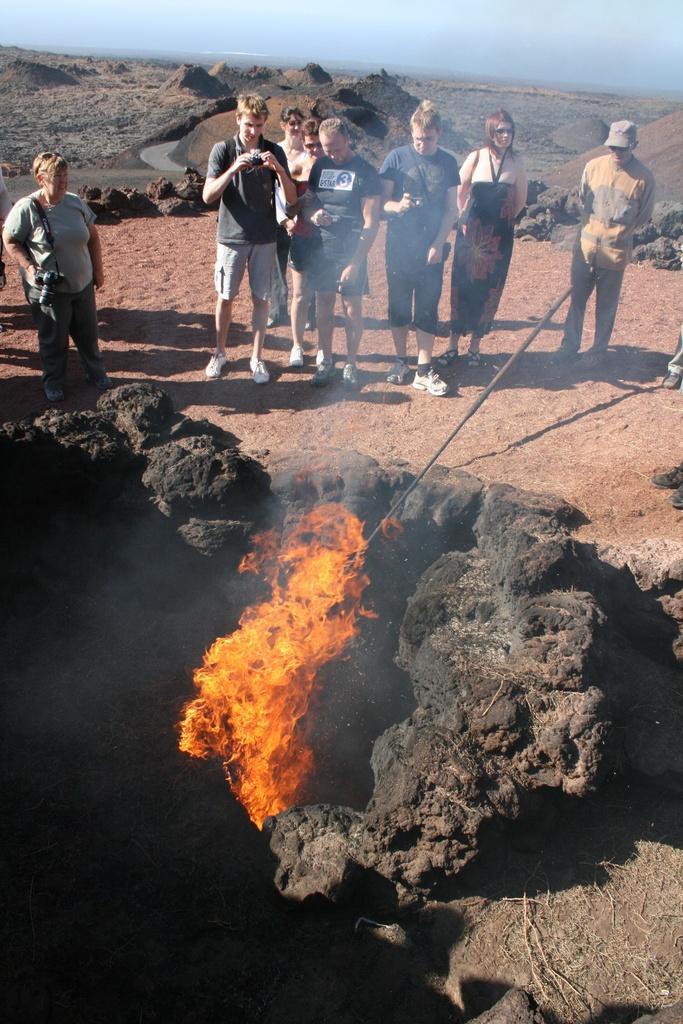Could you give a brief overview of what you see in this image? In the center of the image we can see some persons are standing and some of them are holding cameras. At the bottom of the image we can see the rocks, fire and stick. In the background of the image we can see the mountains, water, rocks and ground. At the top of the image we can see the sky. 